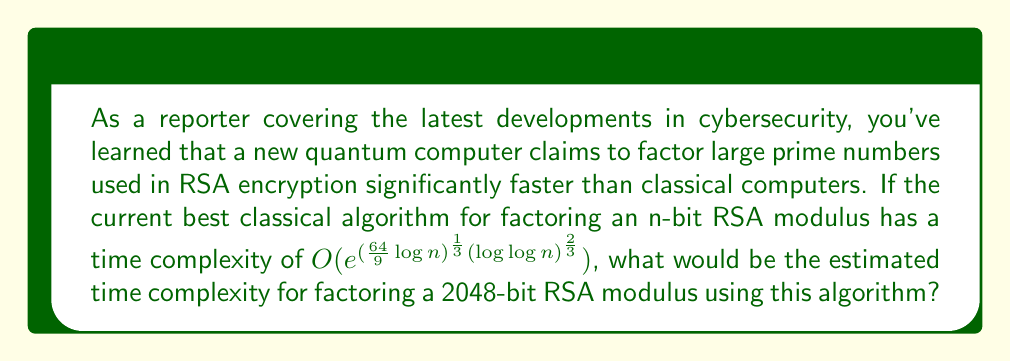Teach me how to tackle this problem. To estimate the time complexity for factoring a 2048-bit RSA modulus, we'll follow these steps:

1) The given time complexity is $O(e^{(\frac{64}{9}\log n)^{\frac{1}{3}}(\log \log n)^{\frac{2}{3}}})$, where n is the number of bits in the RSA modulus.

2) We're asked about a 2048-bit RSA modulus, so n = 2048.

3) Let's break down the exponent:
   $$(\frac{64}{9}\log n)^{\frac{1}{3}}(\log \log n)^{\frac{2}{3}}$$

4) Calculate $\log n$:
   $\log 2048 = \log 2^{11} = 11 \log 2 \approx 7.6246$

5) Calculate $\log \log n$:
   $\log \log 2048 = \log 7.6246 \approx 2.0315$

6) Now, let's substitute these values:
   $$(\frac{64}{9} \cdot 7.6246)^{\frac{1}{3}} \cdot (2.0315)^{\frac{2}{3}}$$

7) Simplify:
   $$(54.2838)^{\frac{1}{3}} \cdot (2.0315)^{\frac{2}{3}}$$
   $$= 3.7854 \cdot 1.5940$$
   $$= 6.0339$$

8) Therefore, the time complexity is approximately:
   $$O(e^{6.0339}) \approx O(416.86)$$

This means the algorithm would take time proportional to this very large constant factor.
Answer: $O(e^{6.0339})$ or $O(416.86)$ 